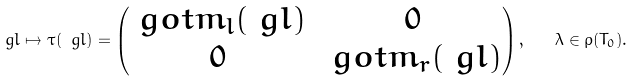<formula> <loc_0><loc_0><loc_500><loc_500>\ g l \mapsto \tau ( \ g l ) = \begin{pmatrix} \ g o t m _ { l } ( \ g l ) & 0 \\ 0 & \ g o t m _ { r } ( \ g l ) \end{pmatrix} , \quad \lambda \in \rho ( T _ { 0 } ) .</formula> 